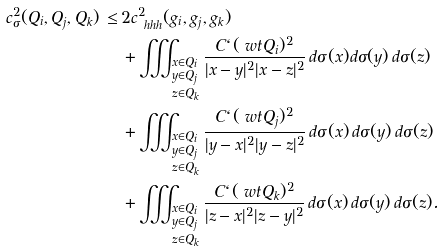<formula> <loc_0><loc_0><loc_500><loc_500>c _ { \sigma } ^ { 2 } ( Q _ { i } , Q _ { j } , Q _ { k } ) \, \leq \, & 2 c ^ { 2 } _ { \ h h h } ( g _ { i } , g _ { j } , g _ { k } ) \\ & + \iiint _ { \begin{subarray} { l } x \in Q _ { i } \\ y \in Q _ { j } \\ z \in Q _ { k } \end{subarray} } \frac { C \ell ( \ w t { Q } _ { i } ) ^ { 2 } } { | x - y | ^ { 2 } | x - z | ^ { 2 } } \, d \sigma ( x ) d \sigma ( y ) \, d \sigma ( z ) \\ & + \iiint _ { \begin{subarray} { l } x \in Q _ { i } \\ y \in Q _ { j } \\ z \in Q _ { k } \end{subarray} } \frac { C \ell ( \ w t { Q } _ { j } ) ^ { 2 } } { | y - x | ^ { 2 } | y - z | ^ { 2 } } \, d \sigma ( x ) \, d \sigma ( y ) \, d \sigma ( z ) \\ & + \iiint _ { \begin{subarray} { l } x \in Q _ { i } \\ y \in Q _ { j } \\ z \in Q _ { k } \end{subarray} } \frac { C \ell ( \ w t { Q } _ { k } ) ^ { 2 } } { | z - x | ^ { 2 } | z - y | ^ { 2 } } \, d \sigma ( x ) \, d \sigma ( y ) \, d \sigma ( z ) .</formula> 